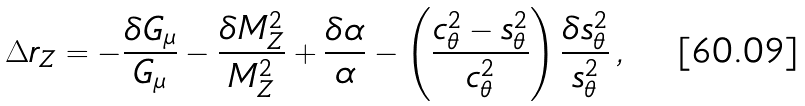<formula> <loc_0><loc_0><loc_500><loc_500>\Delta r _ { Z } = - \frac { \delta G _ { \mu } } { G _ { \mu } } - \frac { \delta M _ { Z } ^ { 2 } } { M _ { Z } ^ { 2 } } + \frac { \delta \alpha } { \alpha } - \left ( \frac { c _ { \theta } ^ { 2 } - s _ { \theta } ^ { 2 } } { c _ { \theta } ^ { 2 } } \right ) \frac { \delta s _ { \theta } ^ { 2 } } { s _ { \theta } ^ { 2 } } \, ,</formula> 